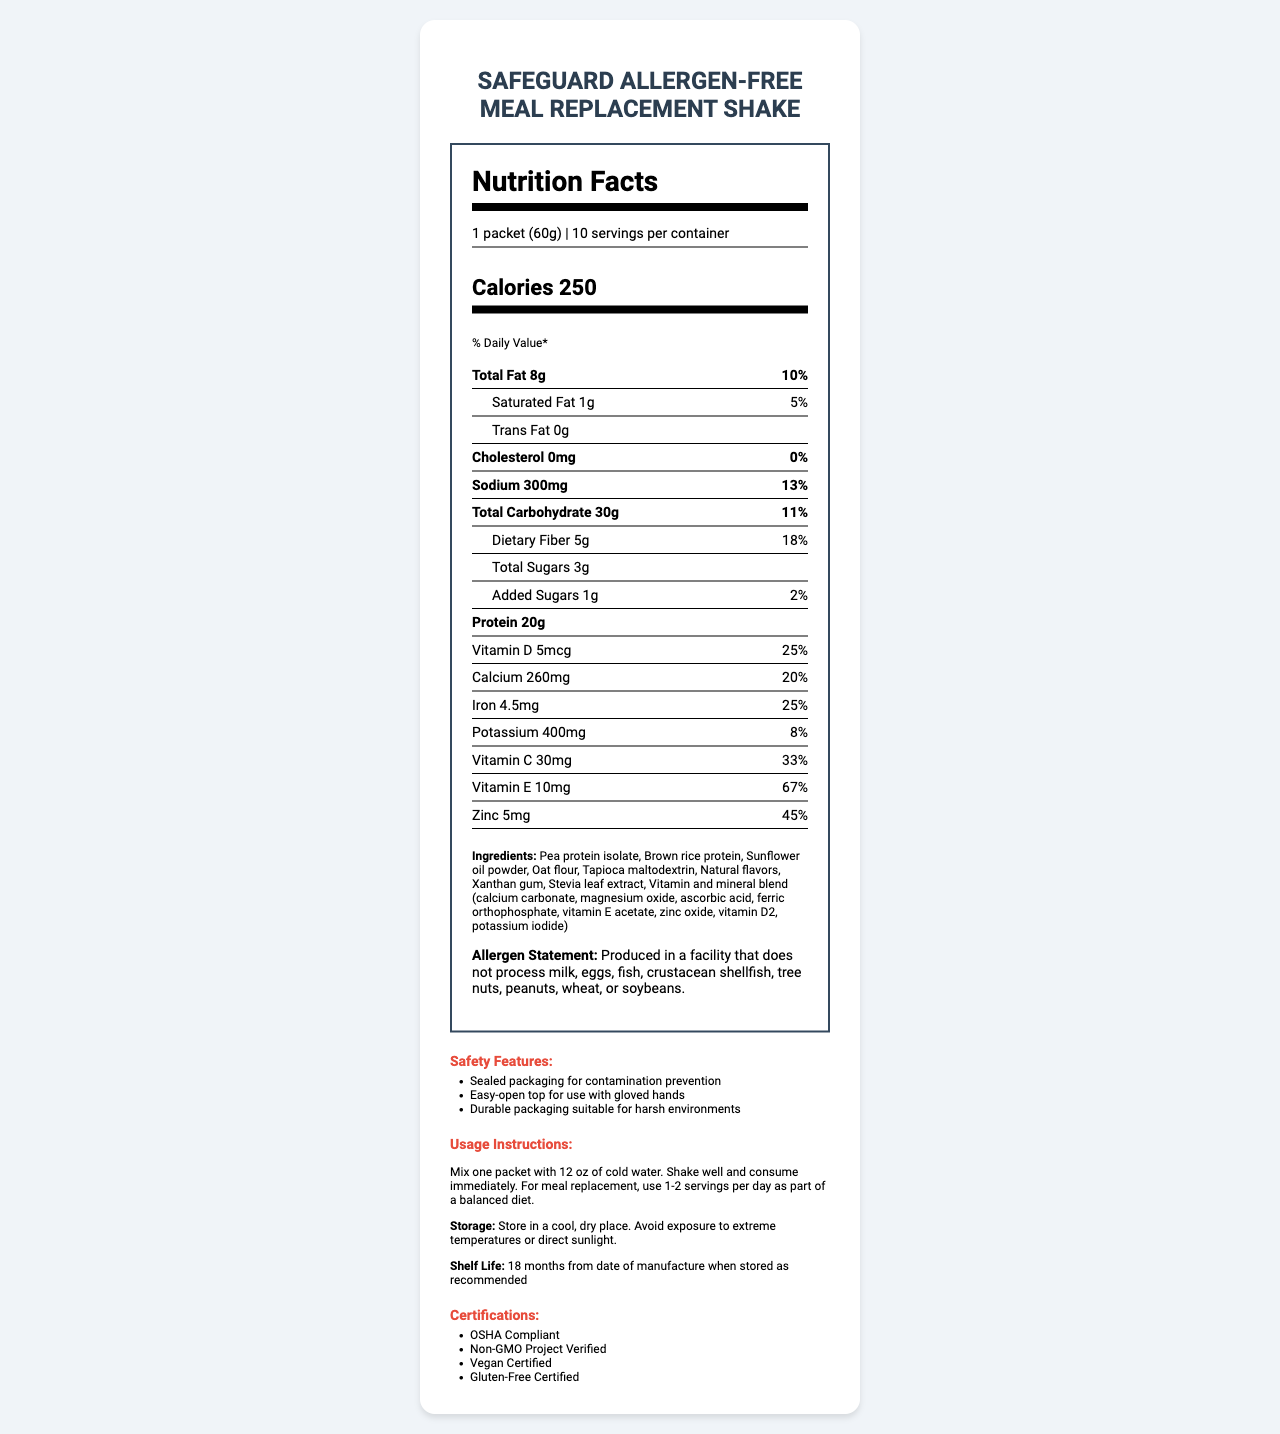What is the serving size for the SafeGuard Allergen-Free Meal Replacement Shake? The document states that the serving size for the SafeGuard Allergen-Free Meal Replacement Shake is "1 packet (60g)."
Answer: 1 packet (60g) How many calories are in one serving of the shake? The calorie content of one serving is listed as "Calories 250" in the document.
Answer: 250 calories What is the total fat content per serving? The total fat content per serving is specified as "Total Fat 8g" in the nutrition label.
Answer: 8g How much protein is in one serving of the shake? The document indicates that one serving contains "Protein 20g."
Answer: 20g Which of the following vitamins or minerals has the highest daily value percentage in one serving? A. Vitamin C B. Vitamin E C. Iron The daily value percentages are Vitamin C 33%, Vitamin E 67%, and Iron 25%. Vitamin E has the highest daily value percentage.
Answer: B What type of facility is the SafeGuard Meal Replacement Shake produced in, according to the allergen statement? The allergen statement specifies that it is produced in a facility that does not process any of these allergens.
Answer: Produced in a facility that does not process milk, eggs, fish, crustacean shellfish, tree nuts, peanuts, wheat, or soybeans. Does the document specify the product's compliance with any certifications? The certifications listed in the document include OSHA Compliant, Non-GMO Project Verified, Vegan Certified, and Gluten-Free Certified.
Answer: Yes What is the shelf life of the product? The document mentions that the shelf life is "18 months from date of manufacture when stored as recommended."
Answer: 18 months from date of manufacture when stored as recommended Is the shake suitable for a vegan diet? The document lists "Vegan Certified" among its certifications, indicating suitability for a vegan diet.
Answer: Yes Describe the main idea of this document. The document is a comprehensive overview of the SafeGuard Allergen-Free Meal Replacement Shake, highlighting its nutritional content, compliance with dietary restrictions, and suitability for use in hazardous environments.
Answer: The document provides detailed nutritional information, ingredients, allergen statements, safety features, usage instructions, storage recommendations, shelf life, and certifications for the SafeGuard Allergen-Free Meal Replacement Shake, which is designed to meet the nutritional needs of workers in hazardous environments and is allergen-free, vegan, and durable in harsh conditions. What is the primary source of protein in the shake? The document lists multiple ingredients including pea protein isolate and brown rice protein but does not specify which is the primary source of protein.
Answer: Cannot be determined Which feature makes the packaging suitable for harsh environments? A. Natural flavors B. Xanthan gum C. Durable packaging The document mentions "Durable packaging suitable for harsh environments" under safety features, which makes it suitable for harsh environments.
Answer: C 